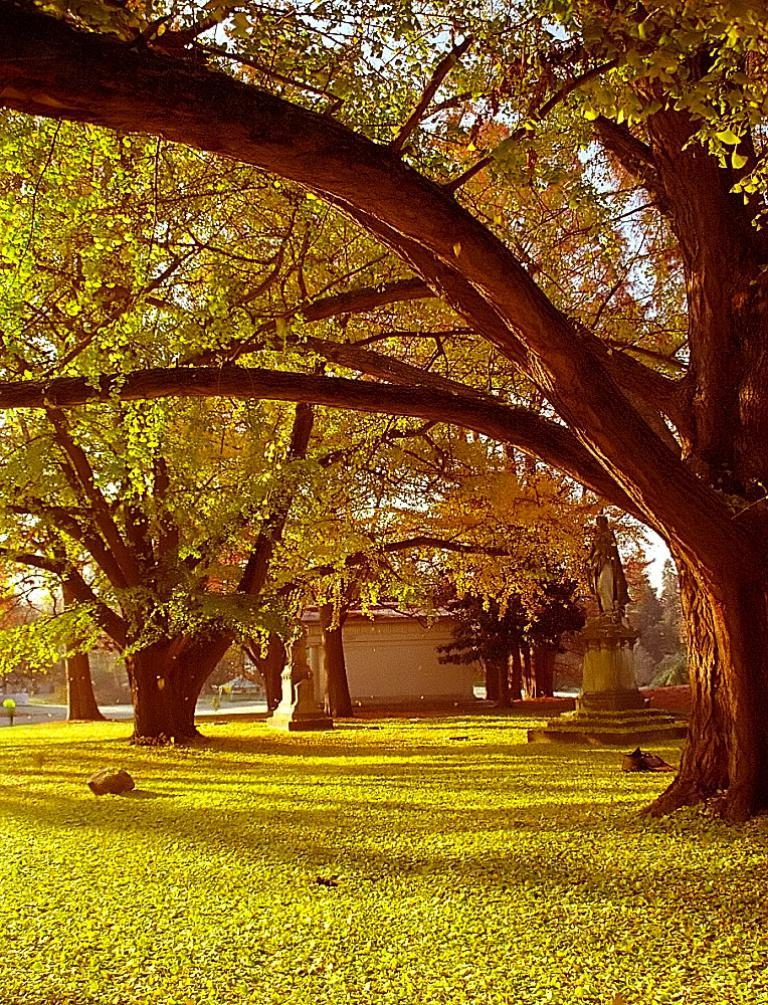What type of vegetation is present in the center of the image? There are trees in the center of the image. What type of ground cover is present in the center of the image? There is grass in the center of the image. What type of man-made objects are present in the center of the image? There are statues in the center of the image. What other objects can be seen in the center of the image? There are a few other objects in the center of the image. How many ducks are swimming in the pond in the image? There is no pond or ducks present in the image. What type of liquid is being dropped from the sky in the image? There is no liquid being dropped from the sky in the image. 